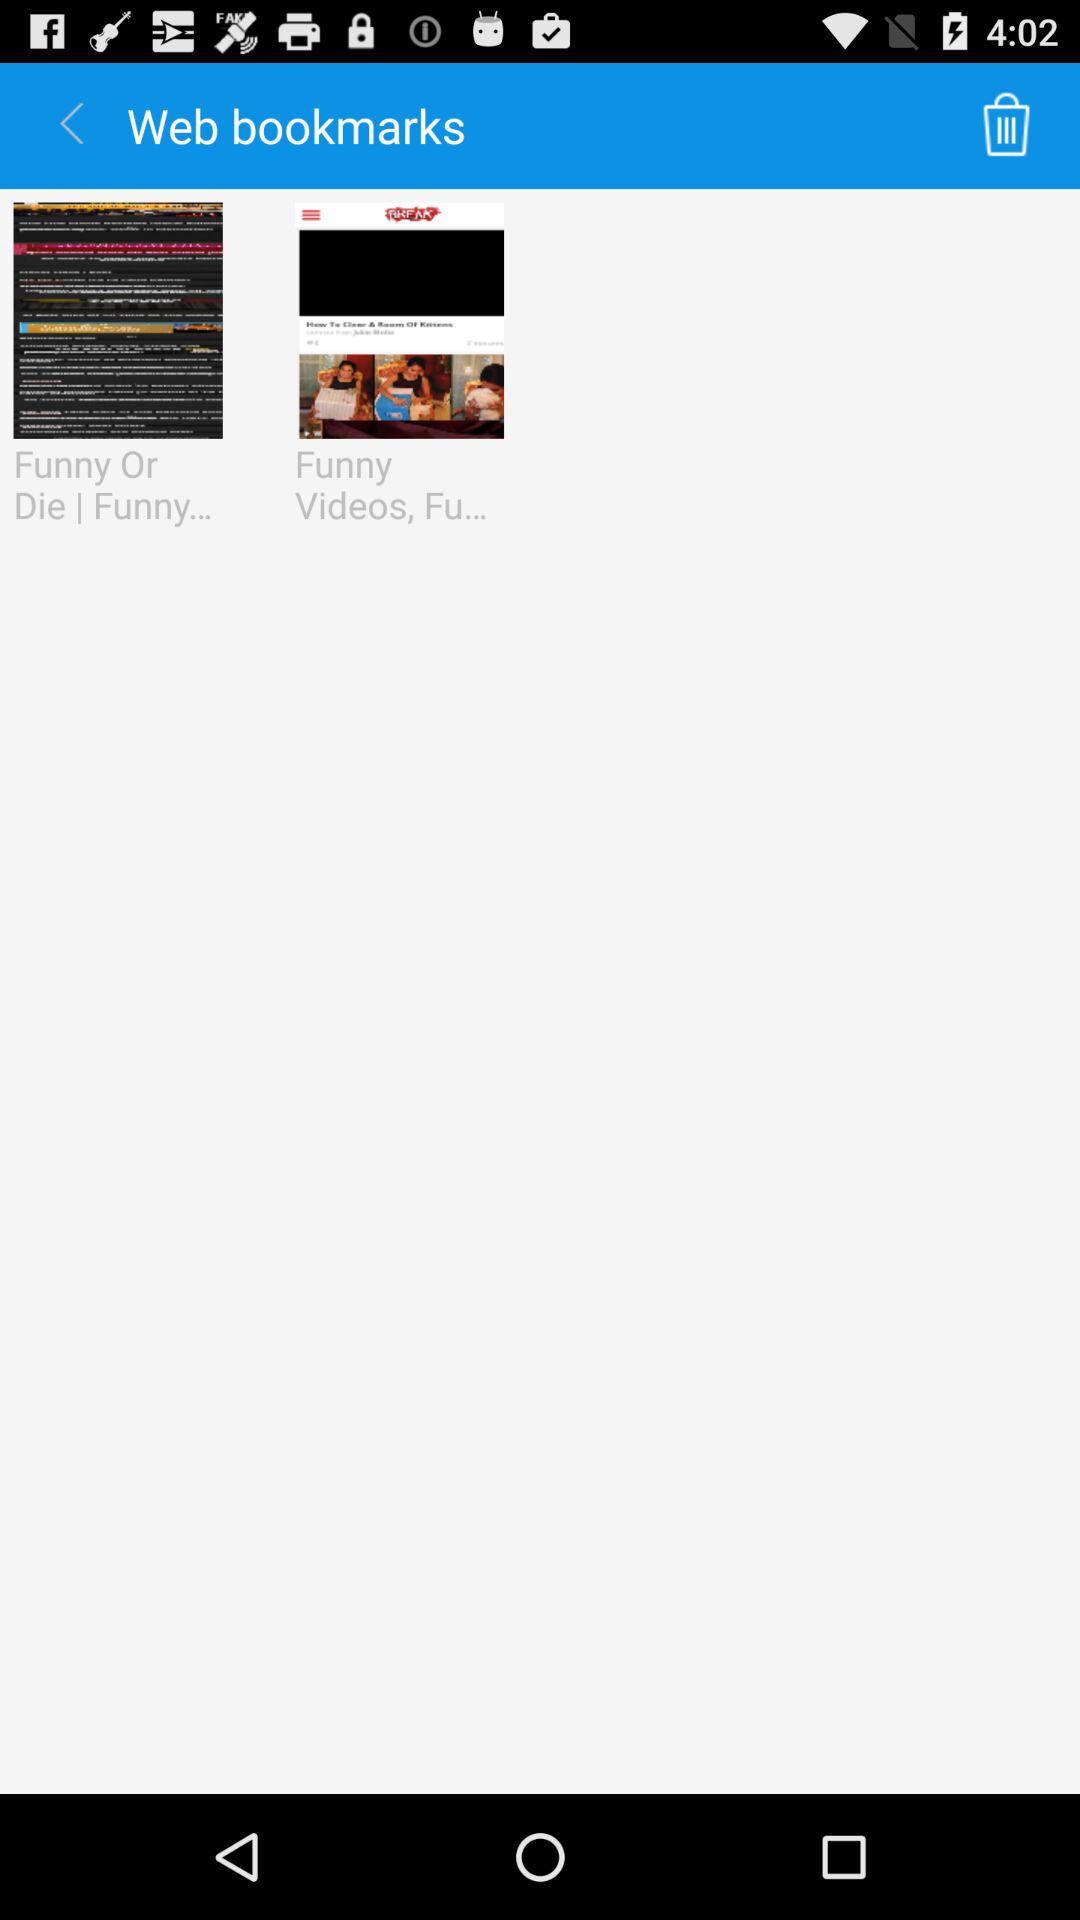What are the contents of web bookmarks? The contents are "Funny Or Die | Funny..." and "Funny Videos, Fu...". 